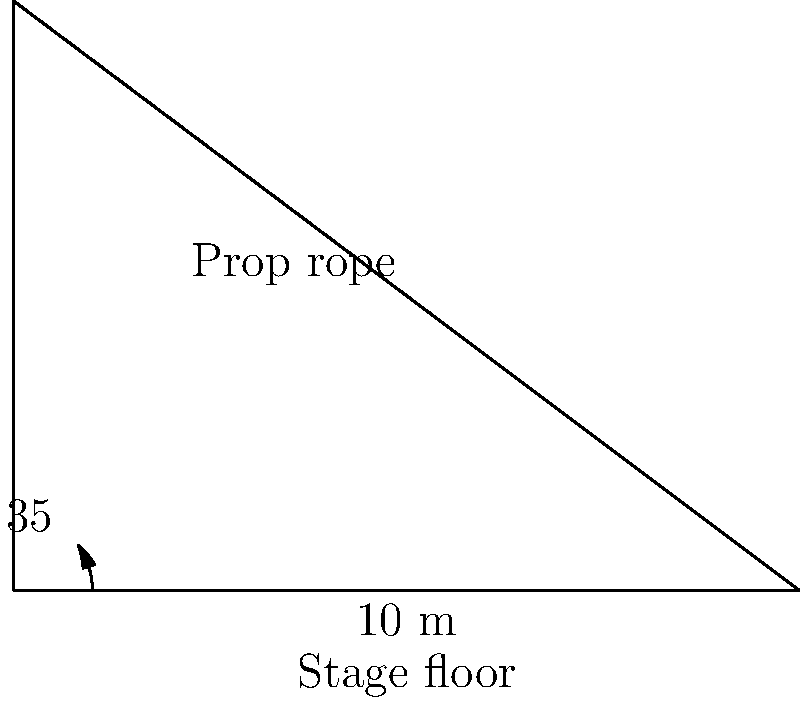In a stage production, you need to hang a prop from the ceiling. The rope used to hang the prop forms a $35°$ angle with the stage floor, and its projection on the floor is $10$ meters long. What is the actual length of the rope needed for this prop? Let's approach this step-by-step:

1) We can visualize this as a right triangle, where:
   - The hypotenuse is the rope we're looking for
   - The adjacent side to the $35°$ angle is the $10$ m projection on the floor
   - The opposite side is the height from the floor to where the rope attaches

2) We're given the adjacent side and the angle, and we need to find the hypotenuse. This calls for the cosine function.

3) The cosine of an angle in a right triangle is defined as:

   $\cos(\theta) = \frac{\text{adjacent}}{\text{hypotenuse}}$

4) Let's call the length of the rope $x$. We can write:

   $\cos(35°) = \frac{10}{x}$

5) To solve for $x$, we multiply both sides by $x$:

   $x \cdot \cos(35°) = 10$

6) Then divide both sides by $\cos(35°)$:

   $x = \frac{10}{\cos(35°)}$

7) Now we can calculate:
   $x = \frac{10}{\cos(35°)} \approx 12.21$ meters

Therefore, the rope needed is approximately $12.21$ meters long.
Answer: $12.21$ m 